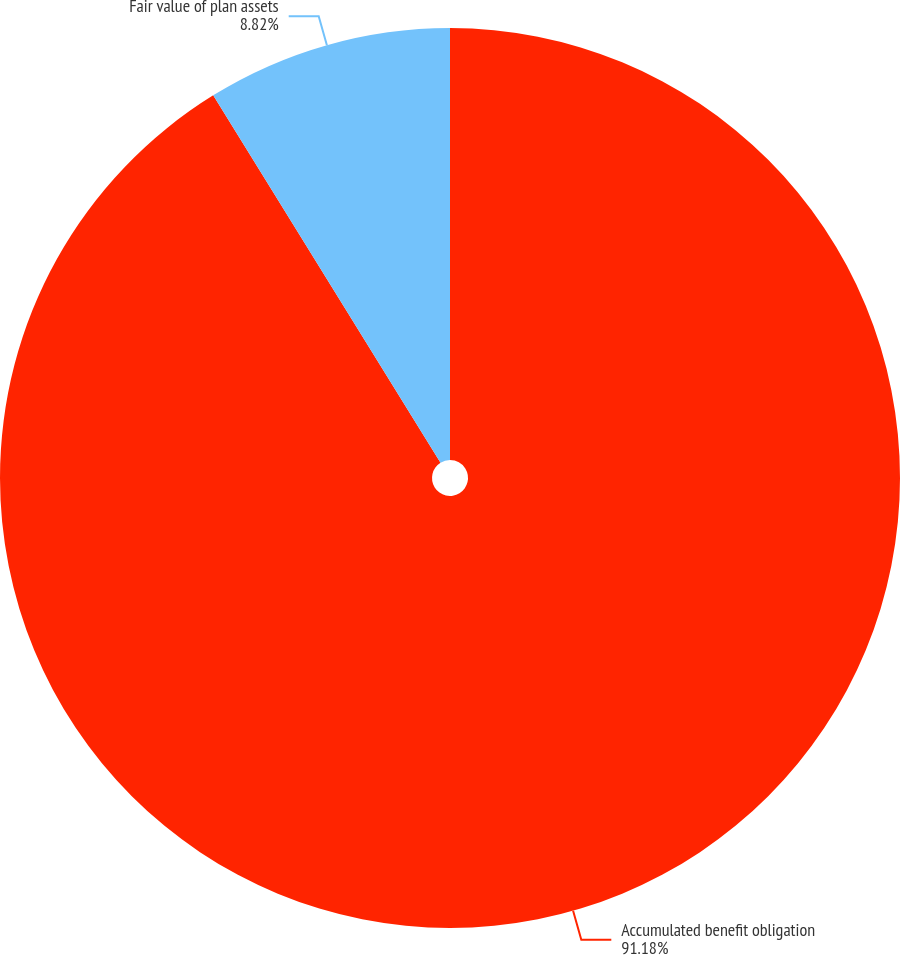<chart> <loc_0><loc_0><loc_500><loc_500><pie_chart><fcel>Accumulated benefit obligation<fcel>Fair value of plan assets<nl><fcel>91.18%<fcel>8.82%<nl></chart> 